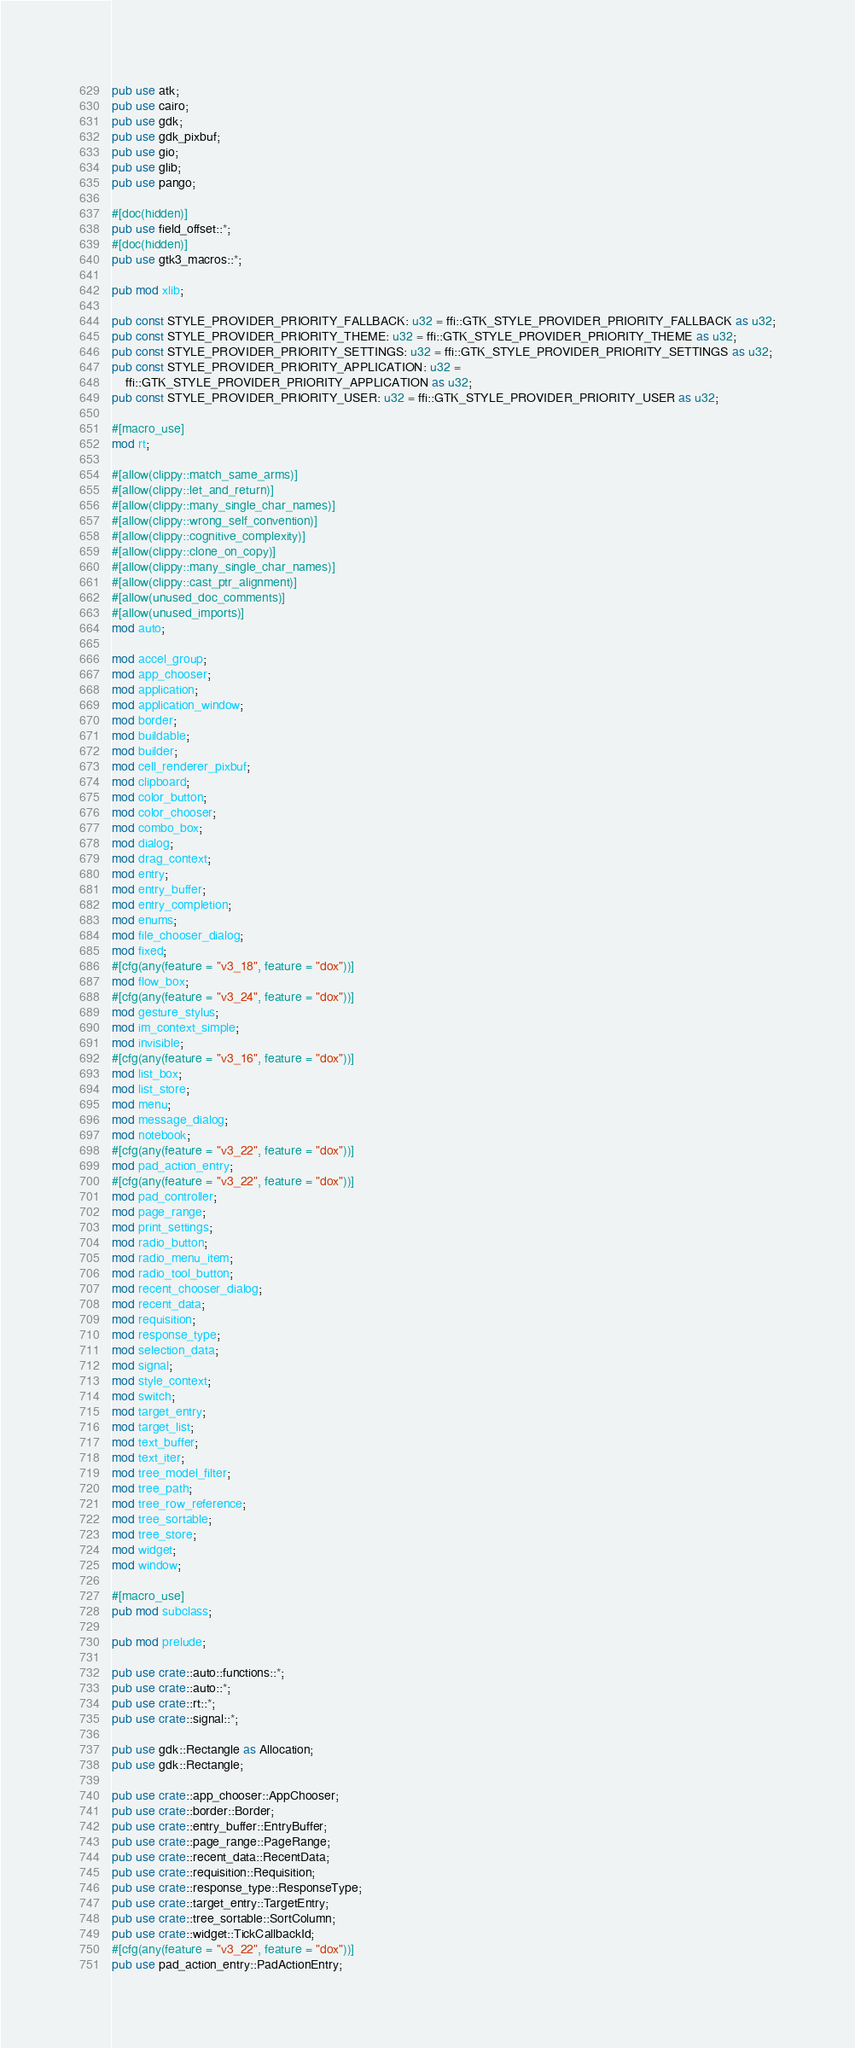Convert code to text. <code><loc_0><loc_0><loc_500><loc_500><_Rust_>pub use atk;
pub use cairo;
pub use gdk;
pub use gdk_pixbuf;
pub use gio;
pub use glib;
pub use pango;

#[doc(hidden)]
pub use field_offset::*;
#[doc(hidden)]
pub use gtk3_macros::*;

pub mod xlib;

pub const STYLE_PROVIDER_PRIORITY_FALLBACK: u32 = ffi::GTK_STYLE_PROVIDER_PRIORITY_FALLBACK as u32;
pub const STYLE_PROVIDER_PRIORITY_THEME: u32 = ffi::GTK_STYLE_PROVIDER_PRIORITY_THEME as u32;
pub const STYLE_PROVIDER_PRIORITY_SETTINGS: u32 = ffi::GTK_STYLE_PROVIDER_PRIORITY_SETTINGS as u32;
pub const STYLE_PROVIDER_PRIORITY_APPLICATION: u32 =
    ffi::GTK_STYLE_PROVIDER_PRIORITY_APPLICATION as u32;
pub const STYLE_PROVIDER_PRIORITY_USER: u32 = ffi::GTK_STYLE_PROVIDER_PRIORITY_USER as u32;

#[macro_use]
mod rt;

#[allow(clippy::match_same_arms)]
#[allow(clippy::let_and_return)]
#[allow(clippy::many_single_char_names)]
#[allow(clippy::wrong_self_convention)]
#[allow(clippy::cognitive_complexity)]
#[allow(clippy::clone_on_copy)]
#[allow(clippy::many_single_char_names)]
#[allow(clippy::cast_ptr_alignment)]
#[allow(unused_doc_comments)]
#[allow(unused_imports)]
mod auto;

mod accel_group;
mod app_chooser;
mod application;
mod application_window;
mod border;
mod buildable;
mod builder;
mod cell_renderer_pixbuf;
mod clipboard;
mod color_button;
mod color_chooser;
mod combo_box;
mod dialog;
mod drag_context;
mod entry;
mod entry_buffer;
mod entry_completion;
mod enums;
mod file_chooser_dialog;
mod fixed;
#[cfg(any(feature = "v3_18", feature = "dox"))]
mod flow_box;
#[cfg(any(feature = "v3_24", feature = "dox"))]
mod gesture_stylus;
mod im_context_simple;
mod invisible;
#[cfg(any(feature = "v3_16", feature = "dox"))]
mod list_box;
mod list_store;
mod menu;
mod message_dialog;
mod notebook;
#[cfg(any(feature = "v3_22", feature = "dox"))]
mod pad_action_entry;
#[cfg(any(feature = "v3_22", feature = "dox"))]
mod pad_controller;
mod page_range;
mod print_settings;
mod radio_button;
mod radio_menu_item;
mod radio_tool_button;
mod recent_chooser_dialog;
mod recent_data;
mod requisition;
mod response_type;
mod selection_data;
mod signal;
mod style_context;
mod switch;
mod target_entry;
mod target_list;
mod text_buffer;
mod text_iter;
mod tree_model_filter;
mod tree_path;
mod tree_row_reference;
mod tree_sortable;
mod tree_store;
mod widget;
mod window;

#[macro_use]
pub mod subclass;

pub mod prelude;

pub use crate::auto::functions::*;
pub use crate::auto::*;
pub use crate::rt::*;
pub use crate::signal::*;

pub use gdk::Rectangle as Allocation;
pub use gdk::Rectangle;

pub use crate::app_chooser::AppChooser;
pub use crate::border::Border;
pub use crate::entry_buffer::EntryBuffer;
pub use crate::page_range::PageRange;
pub use crate::recent_data::RecentData;
pub use crate::requisition::Requisition;
pub use crate::response_type::ResponseType;
pub use crate::target_entry::TargetEntry;
pub use crate::tree_sortable::SortColumn;
pub use crate::widget::TickCallbackId;
#[cfg(any(feature = "v3_22", feature = "dox"))]
pub use pad_action_entry::PadActionEntry;
</code> 